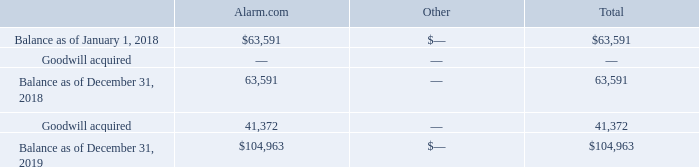Note 8. Goodwill and Intangible Assets, Net
The changes in goodwill by reportable segment are outlined below (in thousands):
On October 21, 2019, we acquired 85% of the issued and outstanding capital stock of OpenEye and recorded $41.4 million of goodwill in the Alarm.com segment. There were no impairments of goodwill recorded during the years ended December 31, 2019, 2018 or 2017. As of December 31, 2019, the accumulated balance of goodwill impairments was $4.8 million, which is related to our acquisition of EnergyHub in 2013.
What was the goodwill acquired in 2019?
Answer scale should be: thousand. 41,372. What was the balance as of December 31, 2019?
Answer scale should be: thousand. 104,963. How much goodwill did the company record in the Alarm.com segment on October 21, 2019?
Answer scale should be: million. $41.4 million. What was the total balance as of January 1, 2018 as a percentage of the total balance on December 31, 2019?
Answer scale should be: percent. 63,591/104,963
Answer: 60.58. What was the difference in goodwill acquired in 2019 and balance as of December 31, 2018?
Answer scale should be: thousand. 63,591-41,372
Answer: 22219. What was the percentage change in the balance between December 31, 2018 and 2019?
Answer scale should be: percent. (104,963-63,591)/63,591
Answer: 65.06. 